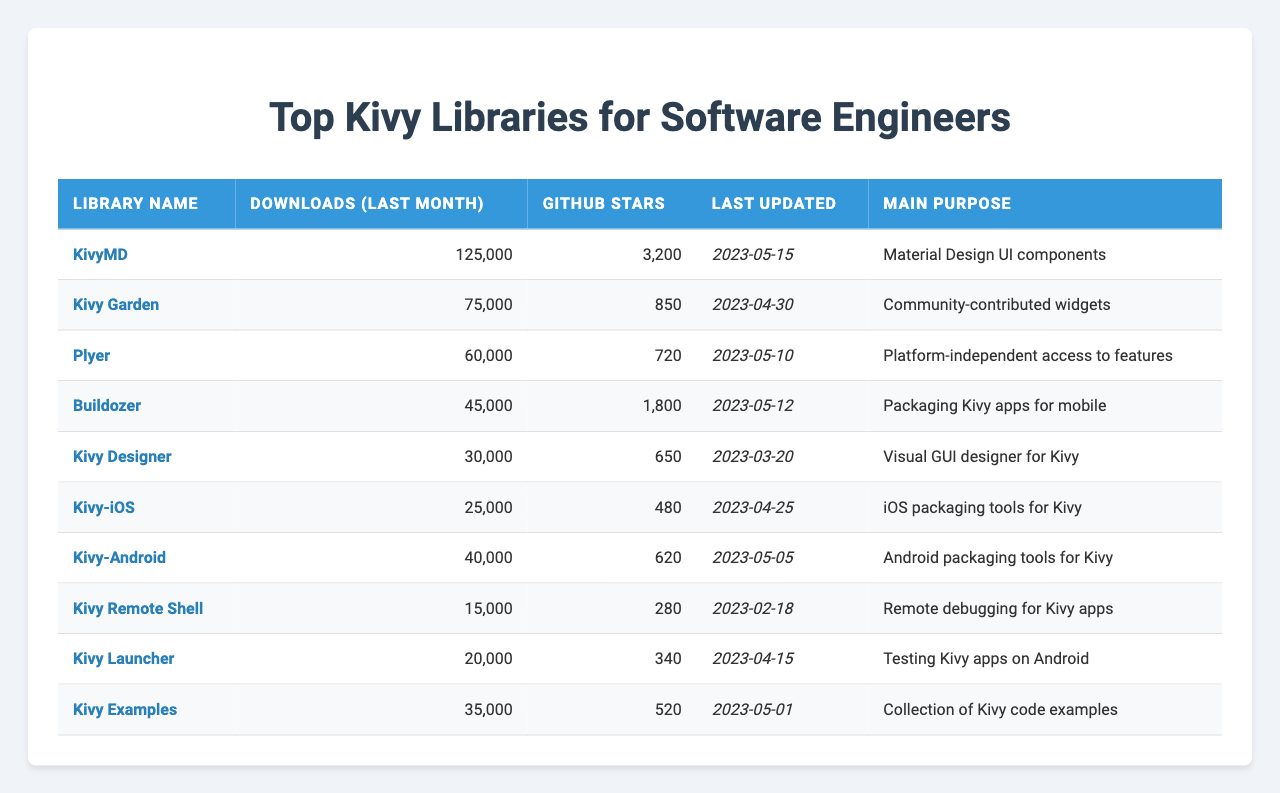What is the library with the highest downloads last month? By examining the "Downloads (Last Month)" column, KivyMD has the highest number of downloads at 125,000.
Answer: KivyMD How many GitHub stars does Kivy Garden have? The "GitHub Stars" column shows that Kivy Garden has 850 stars.
Answer: 850 Which library was last updated on 2023-05-15? By checking the "Last Updated" column, KivyMD was last updated on 2023-05-15.
Answer: KivyMD What is the main purpose of Plyer? Looking at the "Main Purpose" column, Plyer provides platform-independent access to features.
Answer: Platform-independent access to features What library has the least downloads last month? Kivy Remote Shell has the least downloads last month at 15,000, based on the "Downloads (Last Month)" column.
Answer: Kivy Remote Shell What is the average number of downloads for all libraries listed? Summing the downloads gives (125000 + 75000 + 60000 + 45000 + 30000 + 25000 + 40000 + 15000 + 20000 + 35000) = 450000. There are 10 libraries, so the average is 450000 / 10 = 45000.
Answer: 45000 Is Buildozer focused on mobile packaging? Buildozer's main purpose is packaging Kivy apps for mobile, which confirms that it is indeed focused on mobile packaging.
Answer: Yes Which library has more GitHub stars: KivyMD or Kivy Designer? KivyMD has 3200 stars, while Kivy Designer has 650 stars; therefore, KivyMD has more stars than Kivy Designer.
Answer: KivyMD How many libraries were updated after the date of 2023-05-01? The libraries updated after this date are KivyMD (2023-05-15), Plyer (2023-05-10), Buildozer (2023-05-12), Kivy-Android (2023-05-05), and Kivy Examples (2023-05-01), totaling 5 libraries.
Answer: 5 What is the total number of GitHub stars for all libraries combined? The total GitHub stars can be calculated as follows: 3200 + 850 + 720 + 1800 + 650 + 480 + 620 + 280 + 340 + 520 = 10340 stars.
Answer: 10340 